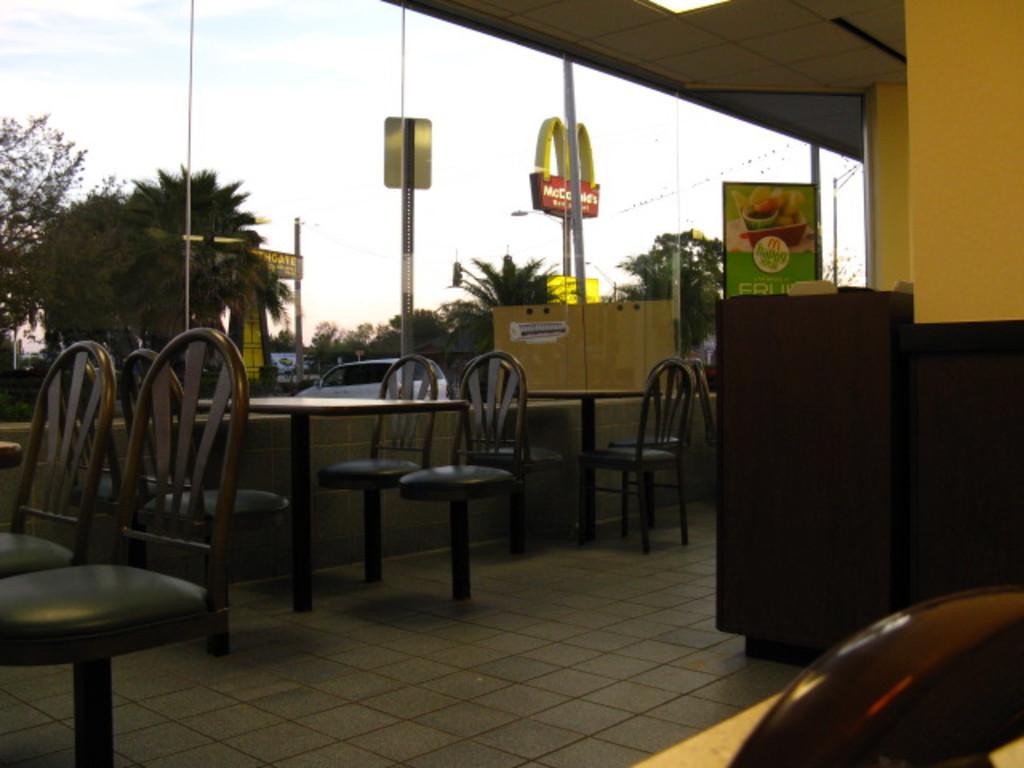How would you summarize this image in a sentence or two? This image looks like a restaurant. At the bottom, there is a floor. In the front, there are chairs along with tables. To the right, there is a wall. In the background, there are trees. At the top, there is a sky. 